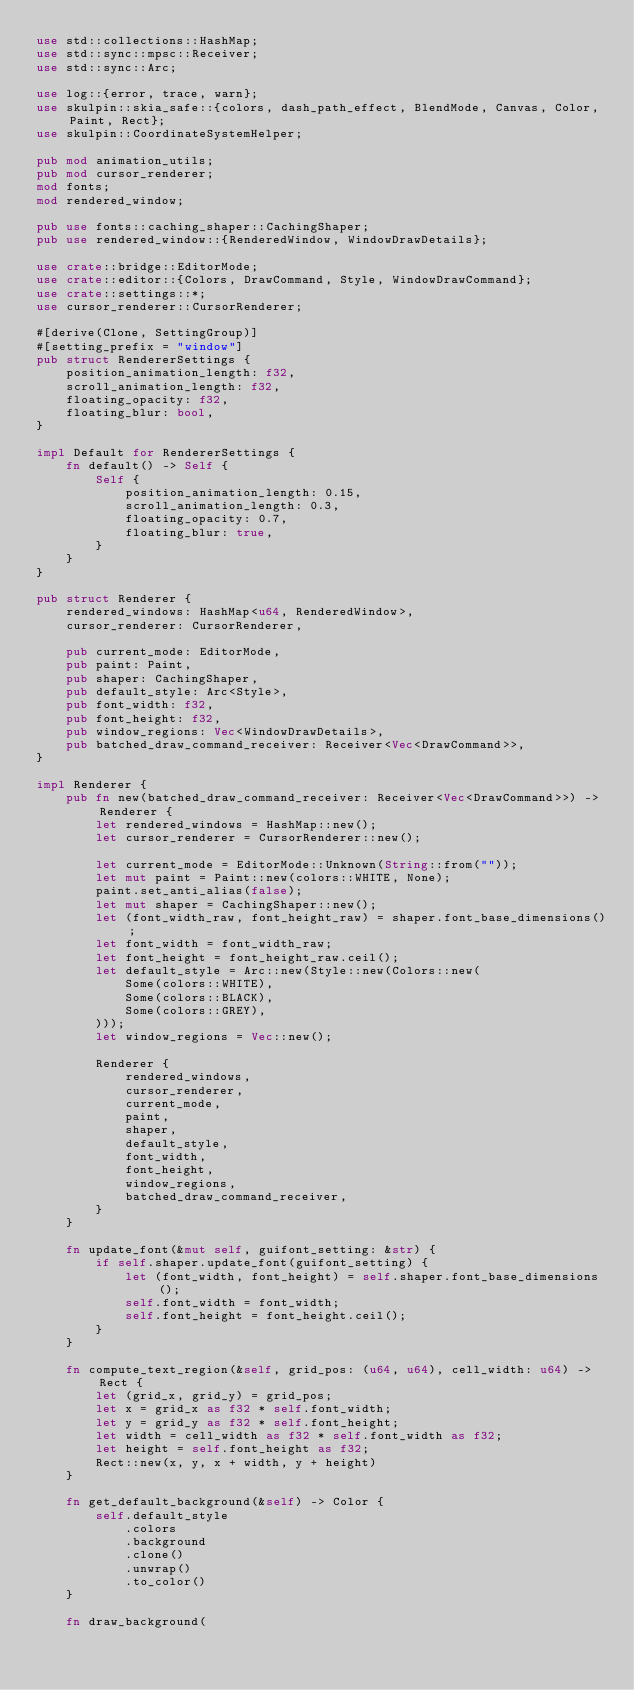Convert code to text. <code><loc_0><loc_0><loc_500><loc_500><_Rust_>use std::collections::HashMap;
use std::sync::mpsc::Receiver;
use std::sync::Arc;

use log::{error, trace, warn};
use skulpin::skia_safe::{colors, dash_path_effect, BlendMode, Canvas, Color, Paint, Rect};
use skulpin::CoordinateSystemHelper;

pub mod animation_utils;
pub mod cursor_renderer;
mod fonts;
mod rendered_window;

pub use fonts::caching_shaper::CachingShaper;
pub use rendered_window::{RenderedWindow, WindowDrawDetails};

use crate::bridge::EditorMode;
use crate::editor::{Colors, DrawCommand, Style, WindowDrawCommand};
use crate::settings::*;
use cursor_renderer::CursorRenderer;

#[derive(Clone, SettingGroup)]
#[setting_prefix = "window"]
pub struct RendererSettings {
    position_animation_length: f32,
    scroll_animation_length: f32,
    floating_opacity: f32,
    floating_blur: bool,
}

impl Default for RendererSettings {
    fn default() -> Self {
        Self {
            position_animation_length: 0.15,
            scroll_animation_length: 0.3,
            floating_opacity: 0.7,
            floating_blur: true,
        }
    }
}

pub struct Renderer {
    rendered_windows: HashMap<u64, RenderedWindow>,
    cursor_renderer: CursorRenderer,

    pub current_mode: EditorMode,
    pub paint: Paint,
    pub shaper: CachingShaper,
    pub default_style: Arc<Style>,
    pub font_width: f32,
    pub font_height: f32,
    pub window_regions: Vec<WindowDrawDetails>,
    pub batched_draw_command_receiver: Receiver<Vec<DrawCommand>>,
}

impl Renderer {
    pub fn new(batched_draw_command_receiver: Receiver<Vec<DrawCommand>>) -> Renderer {
        let rendered_windows = HashMap::new();
        let cursor_renderer = CursorRenderer::new();

        let current_mode = EditorMode::Unknown(String::from(""));
        let mut paint = Paint::new(colors::WHITE, None);
        paint.set_anti_alias(false);
        let mut shaper = CachingShaper::new();
        let (font_width_raw, font_height_raw) = shaper.font_base_dimensions();
        let font_width = font_width_raw;
        let font_height = font_height_raw.ceil();
        let default_style = Arc::new(Style::new(Colors::new(
            Some(colors::WHITE),
            Some(colors::BLACK),
            Some(colors::GREY),
        )));
        let window_regions = Vec::new();

        Renderer {
            rendered_windows,
            cursor_renderer,
            current_mode,
            paint,
            shaper,
            default_style,
            font_width,
            font_height,
            window_regions,
            batched_draw_command_receiver,
        }
    }

    fn update_font(&mut self, guifont_setting: &str) {
        if self.shaper.update_font(guifont_setting) {
            let (font_width, font_height) = self.shaper.font_base_dimensions();
            self.font_width = font_width;
            self.font_height = font_height.ceil();
        }
    }

    fn compute_text_region(&self, grid_pos: (u64, u64), cell_width: u64) -> Rect {
        let (grid_x, grid_y) = grid_pos;
        let x = grid_x as f32 * self.font_width;
        let y = grid_y as f32 * self.font_height;
        let width = cell_width as f32 * self.font_width as f32;
        let height = self.font_height as f32;
        Rect::new(x, y, x + width, y + height)
    }

    fn get_default_background(&self) -> Color {
        self.default_style
            .colors
            .background
            .clone()
            .unwrap()
            .to_color()
    }

    fn draw_background(</code> 